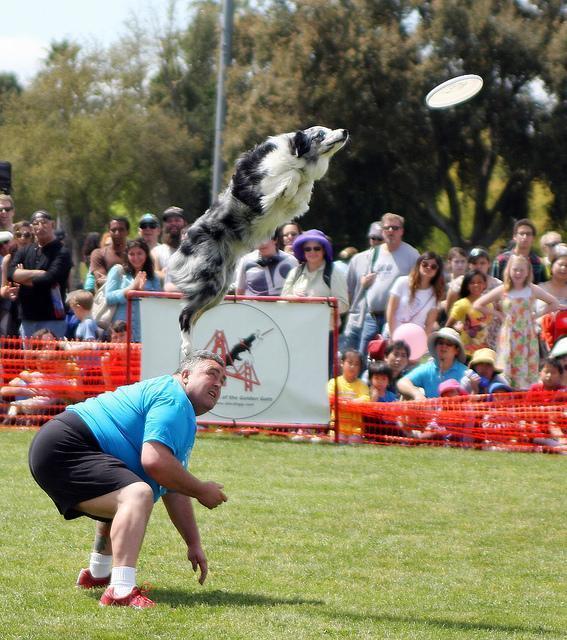How many people can be seen?
Give a very brief answer. 10. 